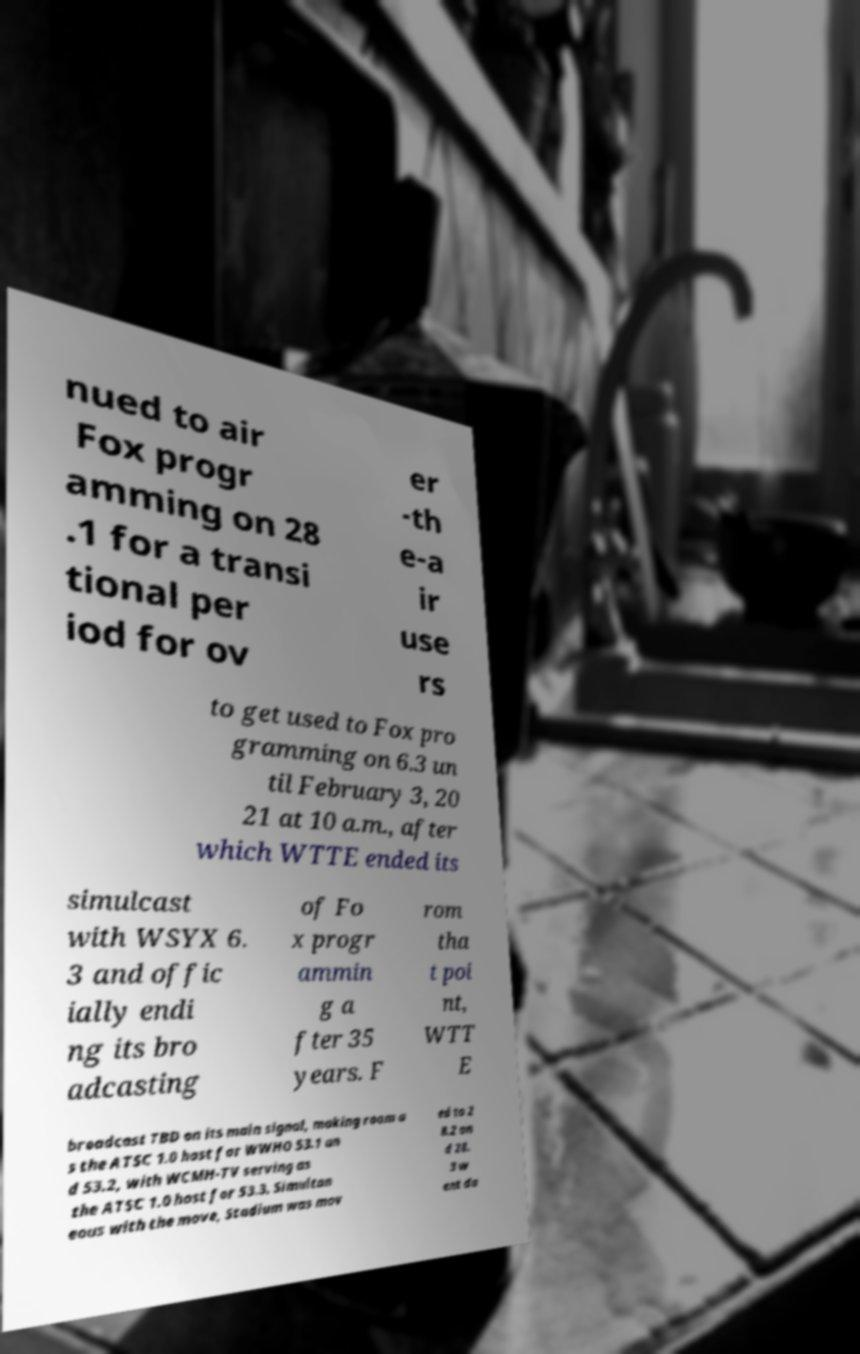What messages or text are displayed in this image? I need them in a readable, typed format. nued to air Fox progr amming on 28 .1 for a transi tional per iod for ov er -th e-a ir use rs to get used to Fox pro gramming on 6.3 un til February 3, 20 21 at 10 a.m., after which WTTE ended its simulcast with WSYX 6. 3 and offic ially endi ng its bro adcasting of Fo x progr ammin g a fter 35 years. F rom tha t poi nt, WTT E broadcast TBD on its main signal, making room a s the ATSC 1.0 host for WWHO 53.1 an d 53.2, with WCMH-TV serving as the ATSC 1.0 host for 53.3. Simultan eous with the move, Stadium was mov ed to 2 8.2 an d 28. 3 w ent da 